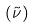<formula> <loc_0><loc_0><loc_500><loc_500>( \tilde { \nu } )</formula> 